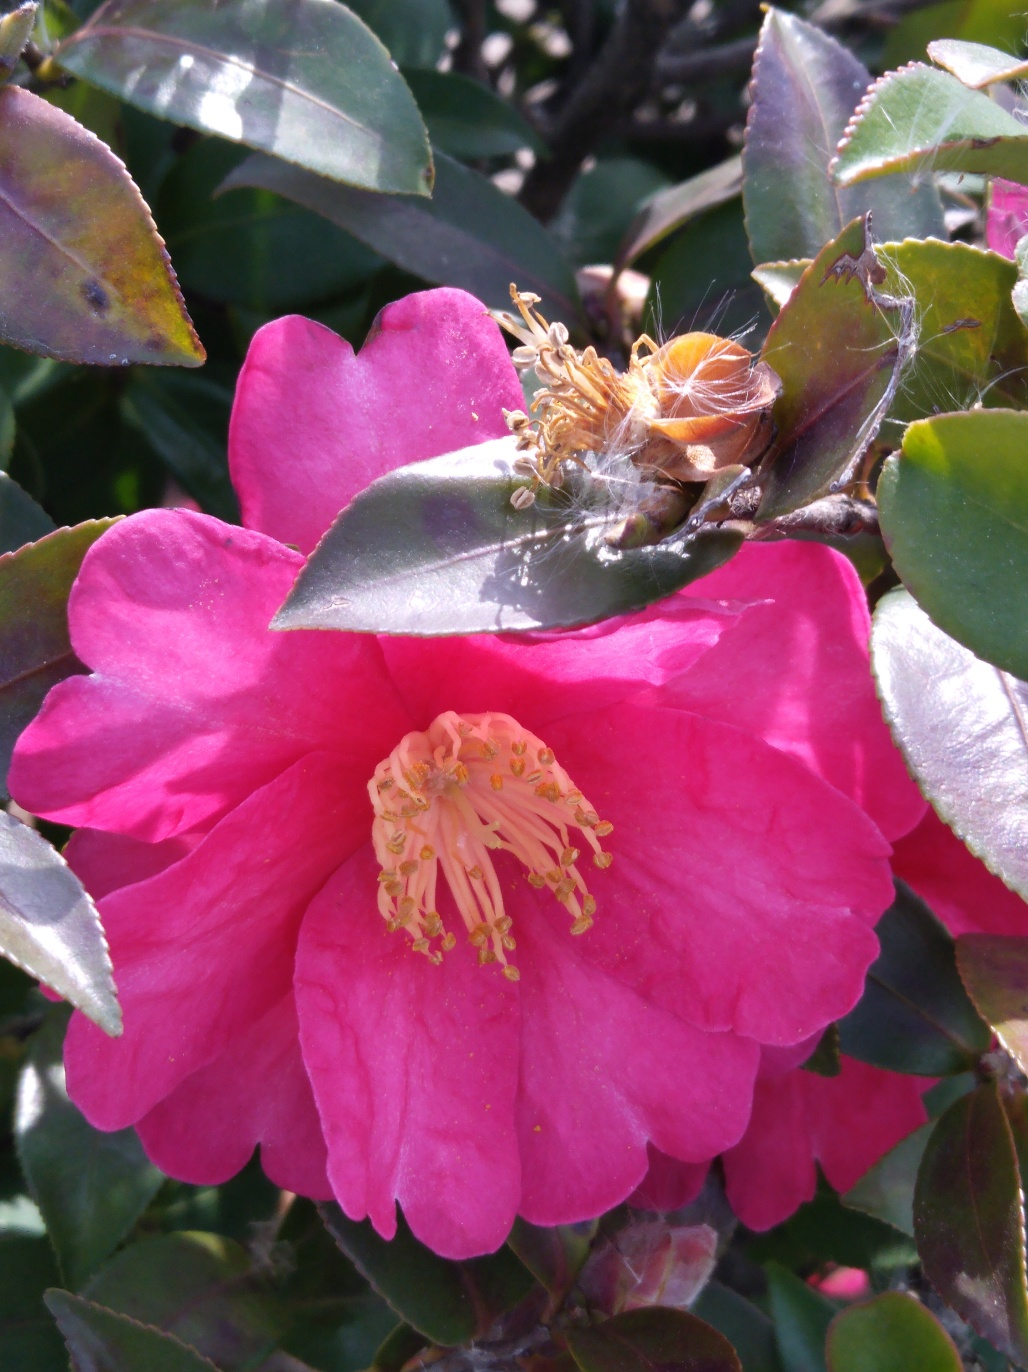Could you explain the condition of the flower in this image? The flower in this image seems to be nearing the end of its bloom, with some petals curling and discoloration apparent on the leaves. The central stamen is fully exposed, indicating that the flower is at a mature stage of its lifecycle. 